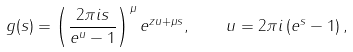<formula> <loc_0><loc_0><loc_500><loc_500>g ( s ) = \left ( \frac { 2 \pi i s } { e ^ { u } - 1 } \right ) ^ { \mu } e ^ { z u + \mu s } , \quad u = 2 \pi i \left ( e ^ { s } - 1 \right ) ,</formula> 